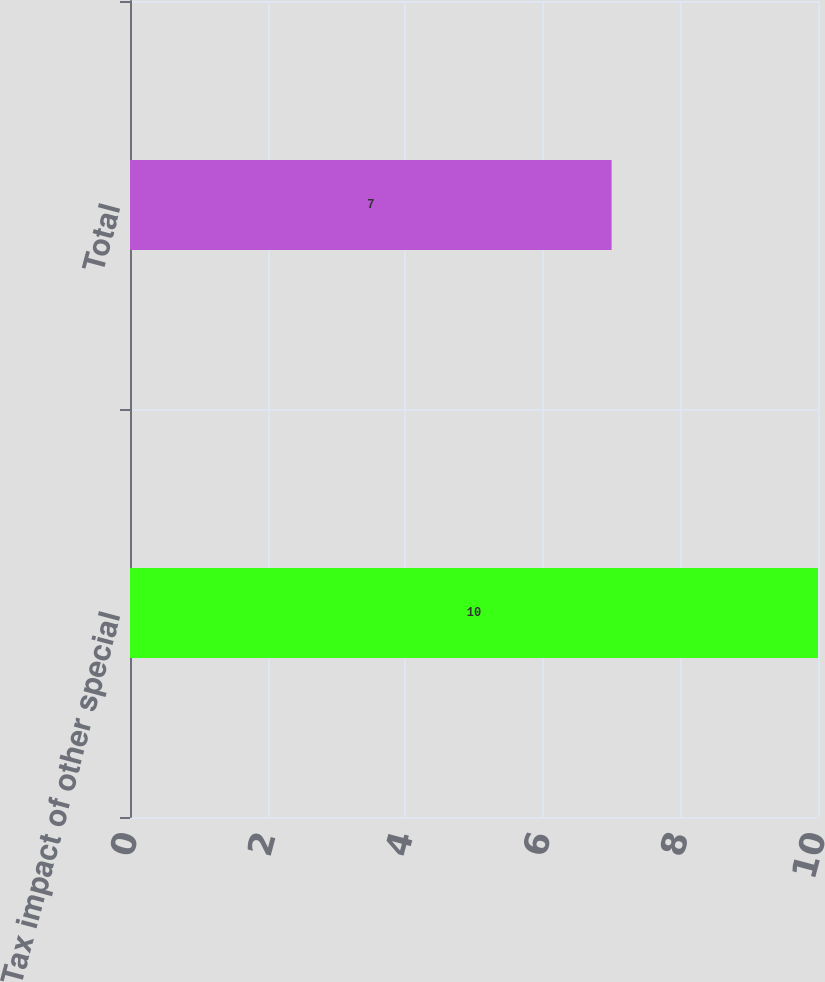<chart> <loc_0><loc_0><loc_500><loc_500><bar_chart><fcel>Tax impact of other special<fcel>Total<nl><fcel>10<fcel>7<nl></chart> 